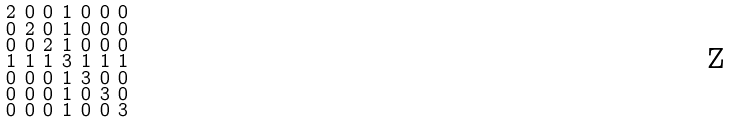Convert formula to latex. <formula><loc_0><loc_0><loc_500><loc_500>\begin{smallmatrix} 2 & 0 & 0 & 1 & 0 & 0 & 0 \\ 0 & 2 & 0 & 1 & 0 & 0 & 0 \\ 0 & 0 & 2 & 1 & 0 & 0 & 0 \\ 1 & 1 & 1 & 3 & 1 & 1 & 1 \\ 0 & 0 & 0 & 1 & 3 & 0 & 0 \\ 0 & 0 & 0 & 1 & 0 & 3 & 0 \\ 0 & 0 & 0 & 1 & 0 & 0 & 3 \end{smallmatrix}</formula> 